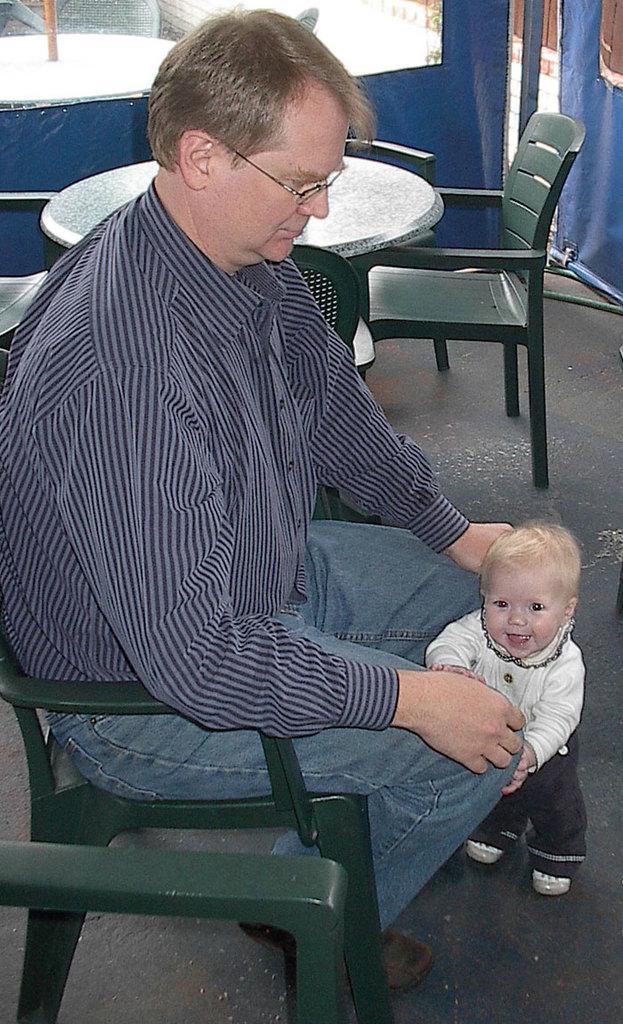Could you give a brief overview of what you see in this image? In the image we can see there is a man who is sitting on the chair which is in green colour and in front of him there is a baby who is standing and at the back there are table and chair. 